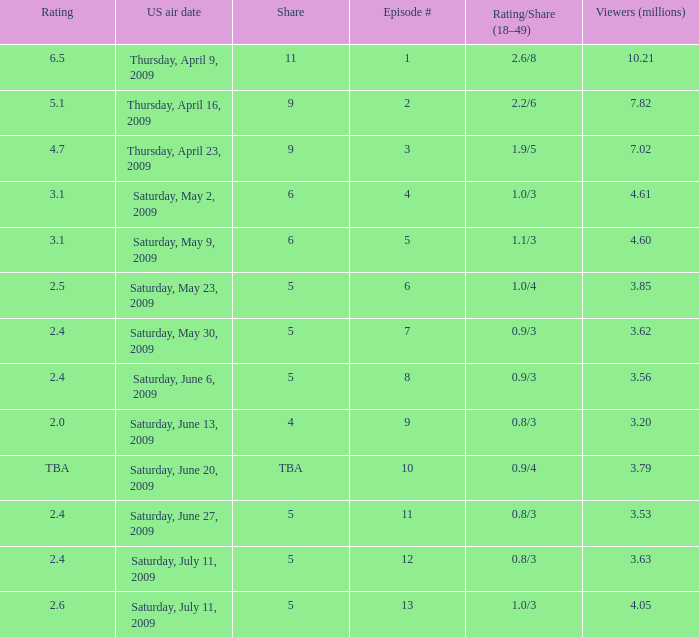I'm looking to parse the entire table for insights. Could you assist me with that? {'header': ['Rating', 'US air date', 'Share', 'Episode #', 'Rating/Share (18–49)', 'Viewers (millions)'], 'rows': [['6.5', 'Thursday, April 9, 2009', '11', '1', '2.6/8', '10.21'], ['5.1', 'Thursday, April 16, 2009', '9', '2', '2.2/6', '7.82'], ['4.7', 'Thursday, April 23, 2009', '9', '3', '1.9/5', '7.02'], ['3.1', 'Saturday, May 2, 2009', '6', '4', '1.0/3', '4.61'], ['3.1', 'Saturday, May 9, 2009', '6', '5', '1.1/3', '4.60'], ['2.5', 'Saturday, May 23, 2009', '5', '6', '1.0/4', '3.85'], ['2.4', 'Saturday, May 30, 2009', '5', '7', '0.9/3', '3.62'], ['2.4', 'Saturday, June 6, 2009', '5', '8', '0.9/3', '3.56'], ['2.0', 'Saturday, June 13, 2009', '4', '9', '0.8/3', '3.20'], ['TBA', 'Saturday, June 20, 2009', 'TBA', '10', '0.9/4', '3.79'], ['2.4', 'Saturday, June 27, 2009', '5', '11', '0.8/3', '3.53'], ['2.4', 'Saturday, July 11, 2009', '5', '12', '0.8/3', '3.63'], ['2.6', 'Saturday, July 11, 2009', '5', '13', '1.0/3', '4.05']]} What is the average number of million viewers that watched an episode before episode 11 with a share of 4? 3.2. 